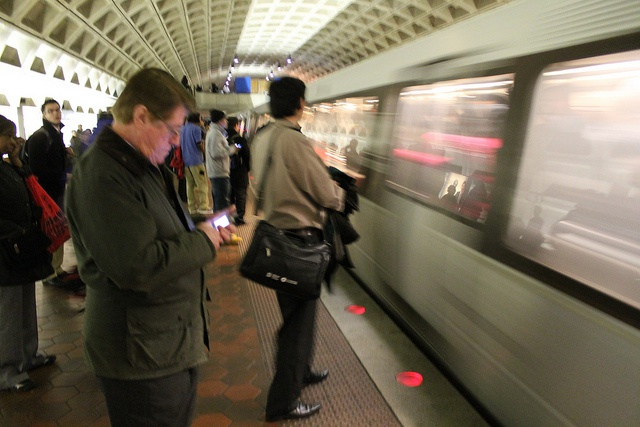Describe the objects in this image and their specific colors. I can see train in olive, gray, tan, darkgray, and lightgray tones, people in olive, black, gray, and brown tones, people in olive, black, and gray tones, people in olive, black, maroon, and darkgreen tones, and handbag in olive, black, and gray tones in this image. 